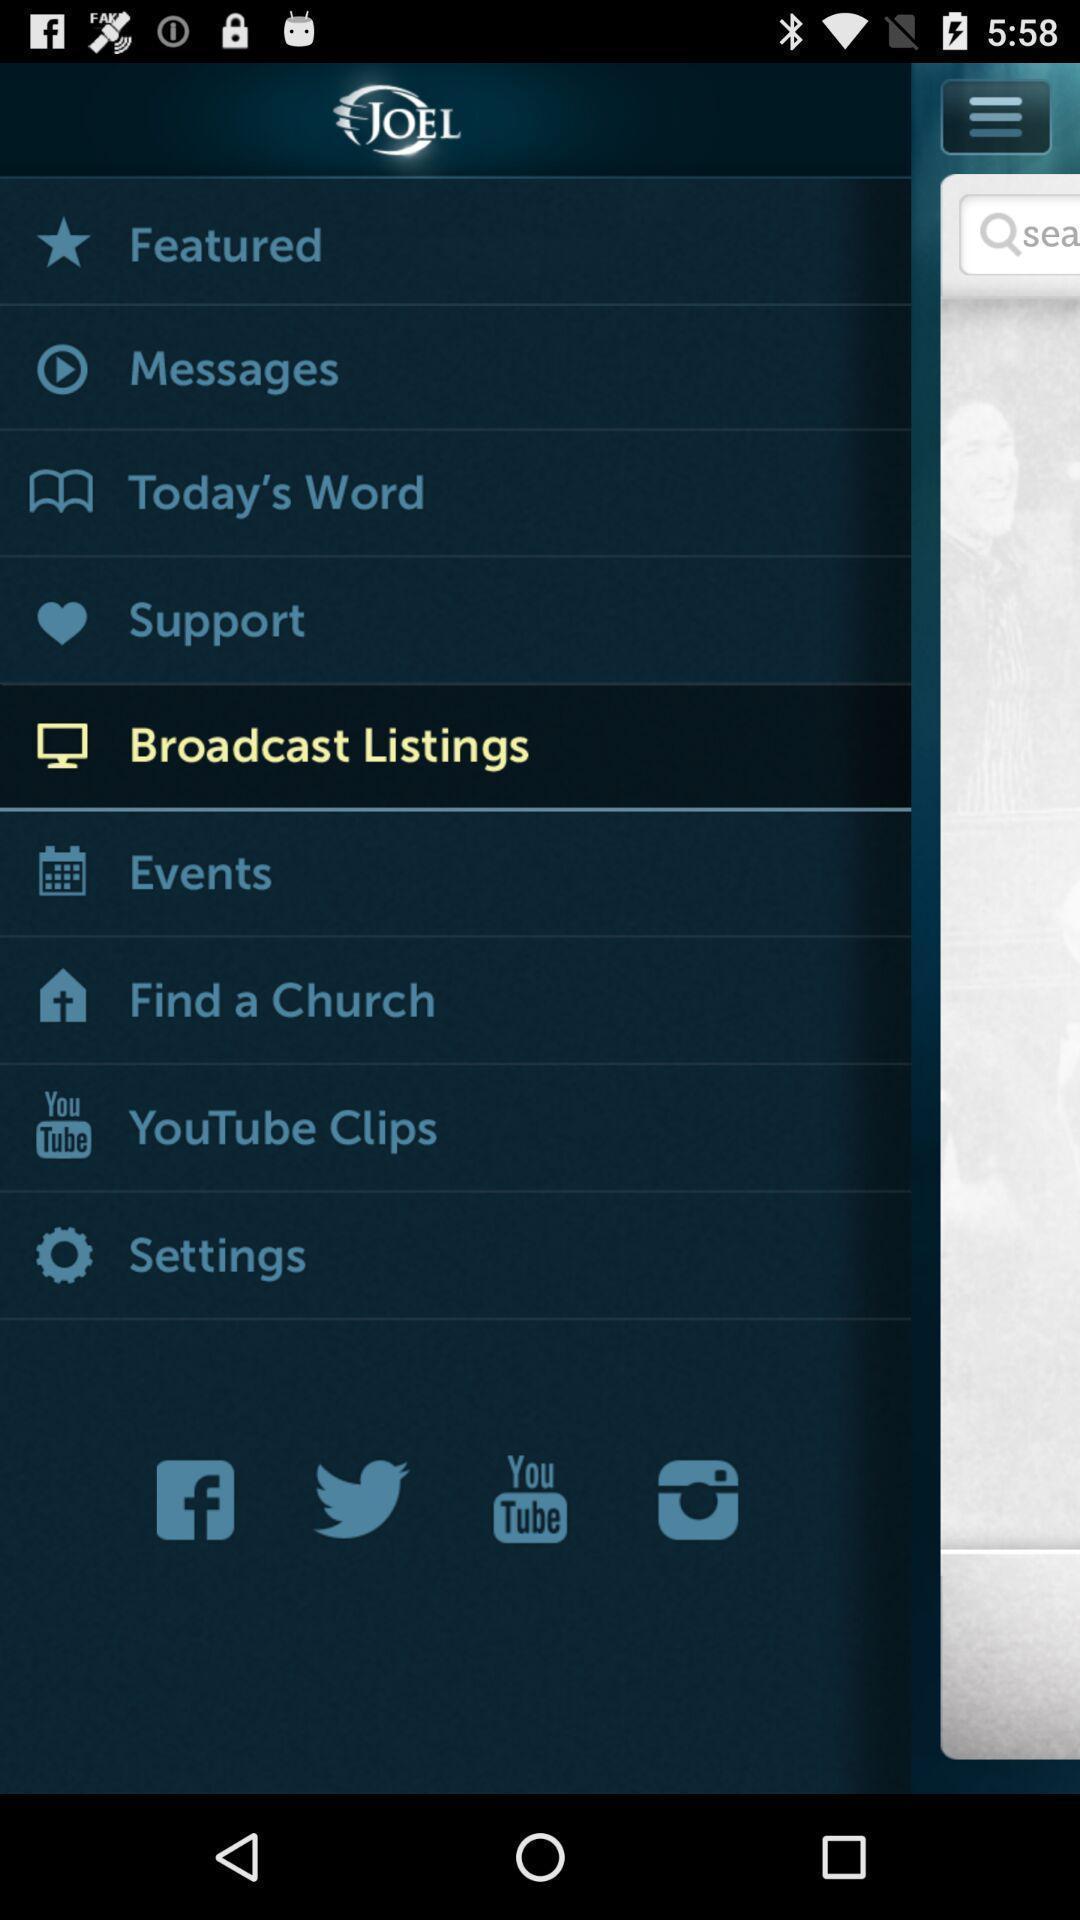Describe the content in this image. Page showing different options. 